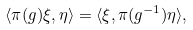Convert formula to latex. <formula><loc_0><loc_0><loc_500><loc_500>\langle \pi ( g ) \xi , \eta \rangle = \langle \xi , \pi ( g ^ { - 1 } ) \eta \rangle ,</formula> 